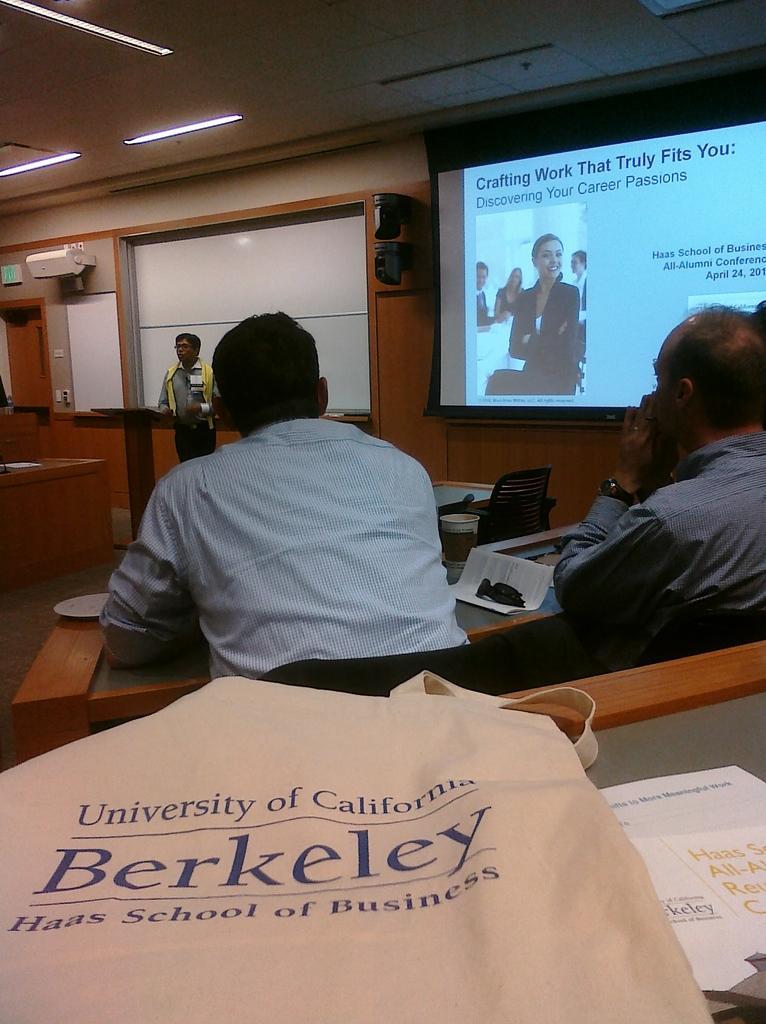In one or two sentences, can you explain what this image depicts? A picture of a room. On top there are lights. A screen is on wall. On this screen a woman is highlighted and smiling. Far this person is standing in-front of this podium. Front this persons are sitting on chairs and in-front of them there is a table, on this tables there are papers and bag. Air conditioner is on wall. 